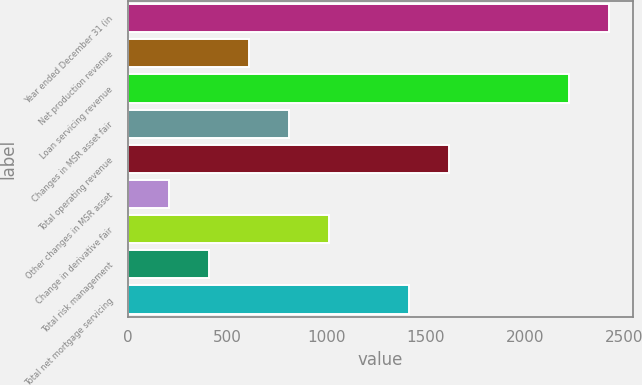<chart> <loc_0><loc_0><loc_500><loc_500><bar_chart><fcel>Year ended December 31 (in<fcel>Net production revenue<fcel>Loan servicing revenue<fcel>Changes in MSR asset fair<fcel>Total operating revenue<fcel>Other changes in MSR asset<fcel>Change in derivative fair<fcel>Total risk management<fcel>Total net mortgage servicing<nl><fcel>2421.2<fcel>606.8<fcel>2219.6<fcel>808.4<fcel>1614.8<fcel>203.6<fcel>1010<fcel>405.2<fcel>1413.2<nl></chart> 